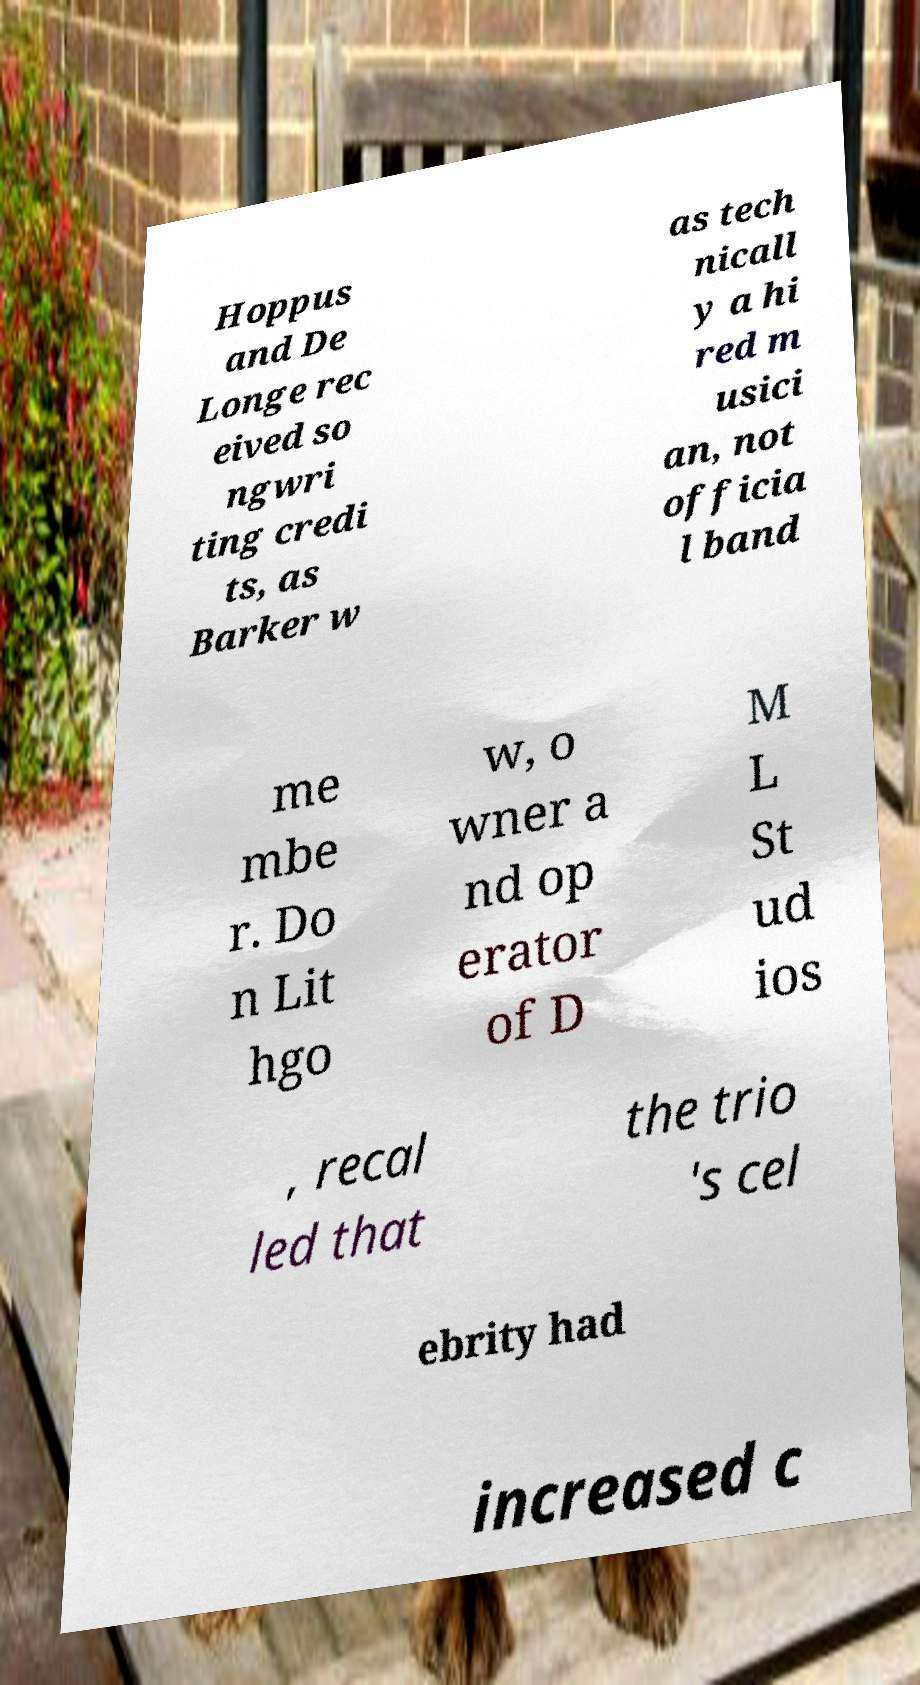What messages or text are displayed in this image? I need them in a readable, typed format. Hoppus and De Longe rec eived so ngwri ting credi ts, as Barker w as tech nicall y a hi red m usici an, not officia l band me mbe r. Do n Lit hgo w, o wner a nd op erator of D M L St ud ios , recal led that the trio 's cel ebrity had increased c 